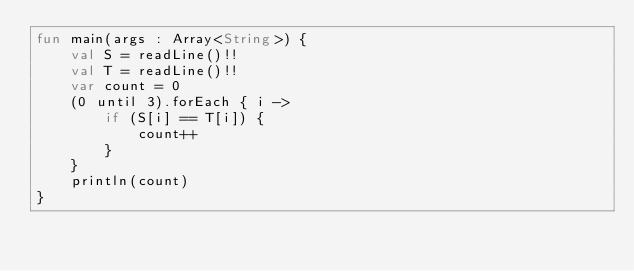<code> <loc_0><loc_0><loc_500><loc_500><_Kotlin_>fun main(args : Array<String>) {
    val S = readLine()!!
    val T = readLine()!!
    var count = 0
    (0 until 3).forEach { i ->
        if (S[i] == T[i]) {
            count++
        }
    }
    println(count)
}</code> 